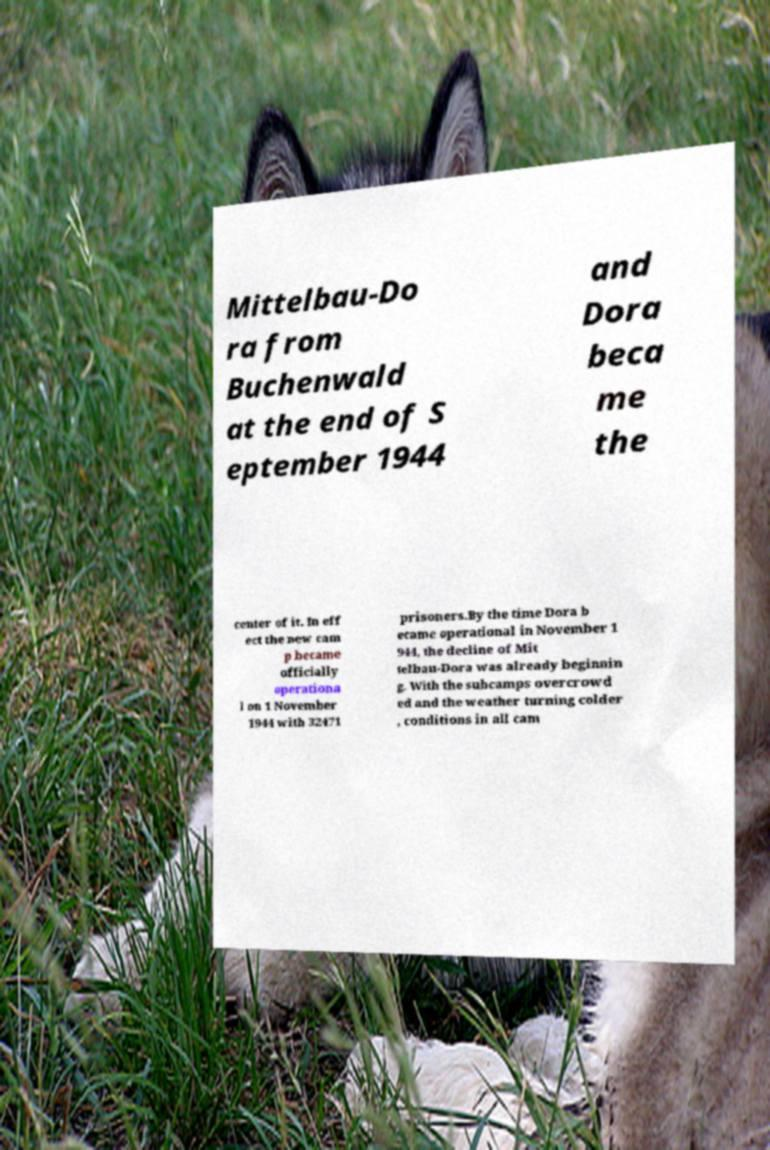What messages or text are displayed in this image? I need them in a readable, typed format. Mittelbau-Do ra from Buchenwald at the end of S eptember 1944 and Dora beca me the center of it. In eff ect the new cam p became officially operationa l on 1 November 1944 with 32471 prisoners.By the time Dora b ecame operational in November 1 944, the decline of Mit telbau-Dora was already beginnin g. With the subcamps overcrowd ed and the weather turning colder , conditions in all cam 